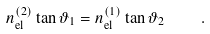<formula> <loc_0><loc_0><loc_500><loc_500>n _ { \text {el} } ^ { ( 2 ) } \tan { \vartheta _ { 1 } } = n _ { \text {el} } ^ { ( 1 ) } \tan { \vartheta _ { 2 } } \quad .</formula> 